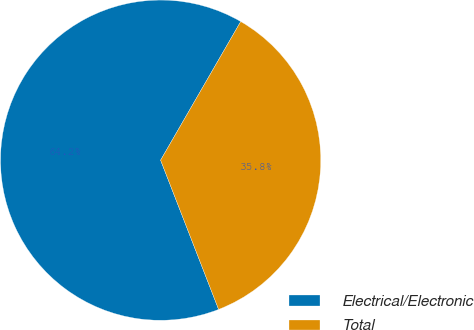<chart> <loc_0><loc_0><loc_500><loc_500><pie_chart><fcel>Electrical/Electronic<fcel>Total<nl><fcel>64.24%<fcel>35.76%<nl></chart> 